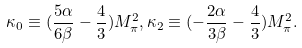<formula> <loc_0><loc_0><loc_500><loc_500>\kappa _ { 0 } \equiv ( \frac { 5 \alpha } { 6 \beta } - \frac { 4 } { 3 } ) M _ { \pi } ^ { 2 } , \kappa _ { 2 } \equiv ( - \frac { 2 \alpha } { 3 \beta } - \frac { 4 } { 3 } ) M _ { \pi } ^ { 2 } .</formula> 